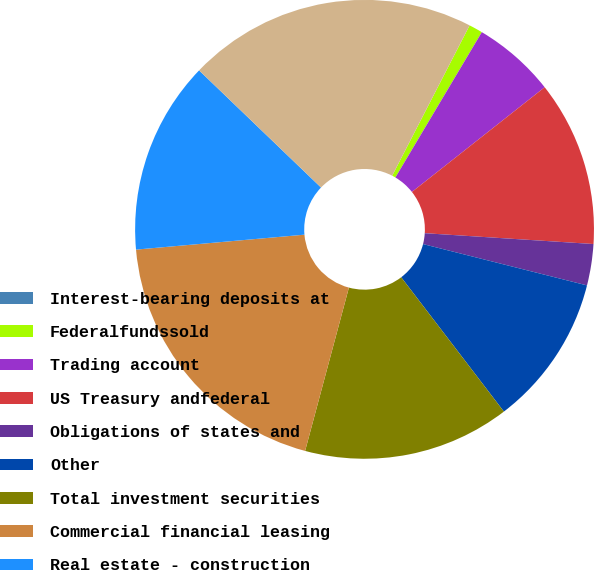Convert chart. <chart><loc_0><loc_0><loc_500><loc_500><pie_chart><fcel>Interest-bearing deposits at<fcel>Federalfundssold<fcel>Trading account<fcel>US Treasury andfederal<fcel>Obligations of states and<fcel>Other<fcel>Total investment securities<fcel>Commercial financial leasing<fcel>Real estate - construction<fcel>Real estate - mortgage<nl><fcel>0.0%<fcel>0.97%<fcel>5.83%<fcel>11.65%<fcel>2.91%<fcel>10.68%<fcel>14.56%<fcel>19.42%<fcel>13.59%<fcel>20.39%<nl></chart> 